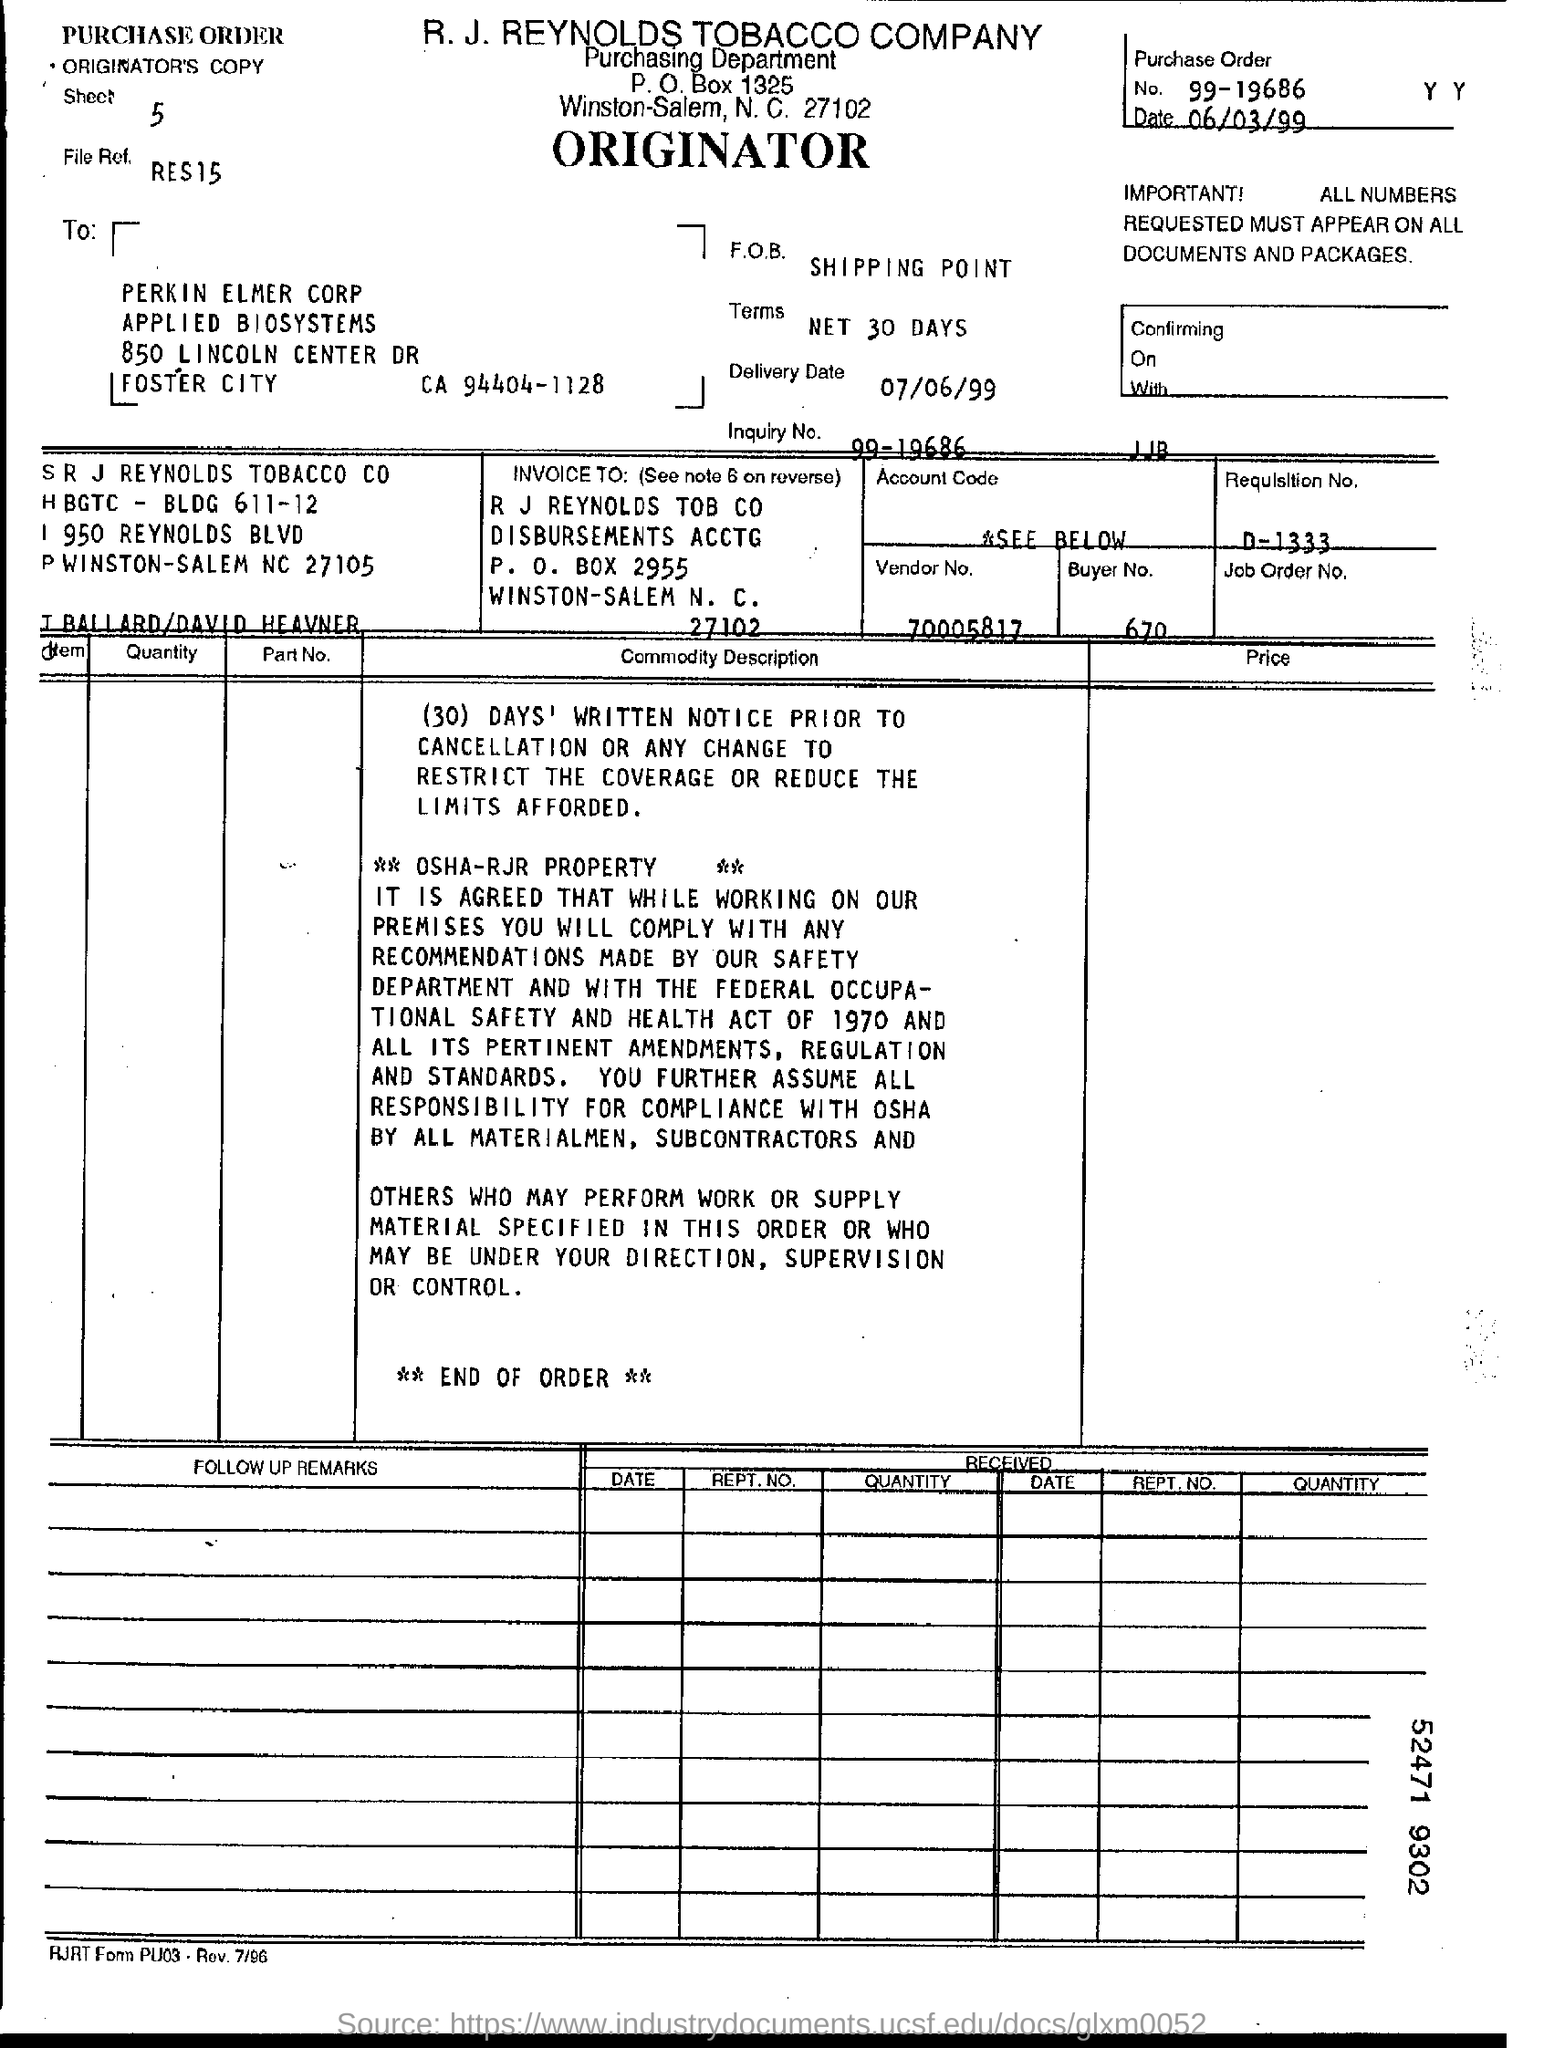Mention a couple of crucial points in this snapshot. The vendor number is 70005817. Can you please provide the purchase order number for 99-19686...? The P.O. box number is 2955. The requirement number is D-1333. The buyer number is 670. 